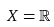<formula> <loc_0><loc_0><loc_500><loc_500>X = \mathbb { R }</formula> 